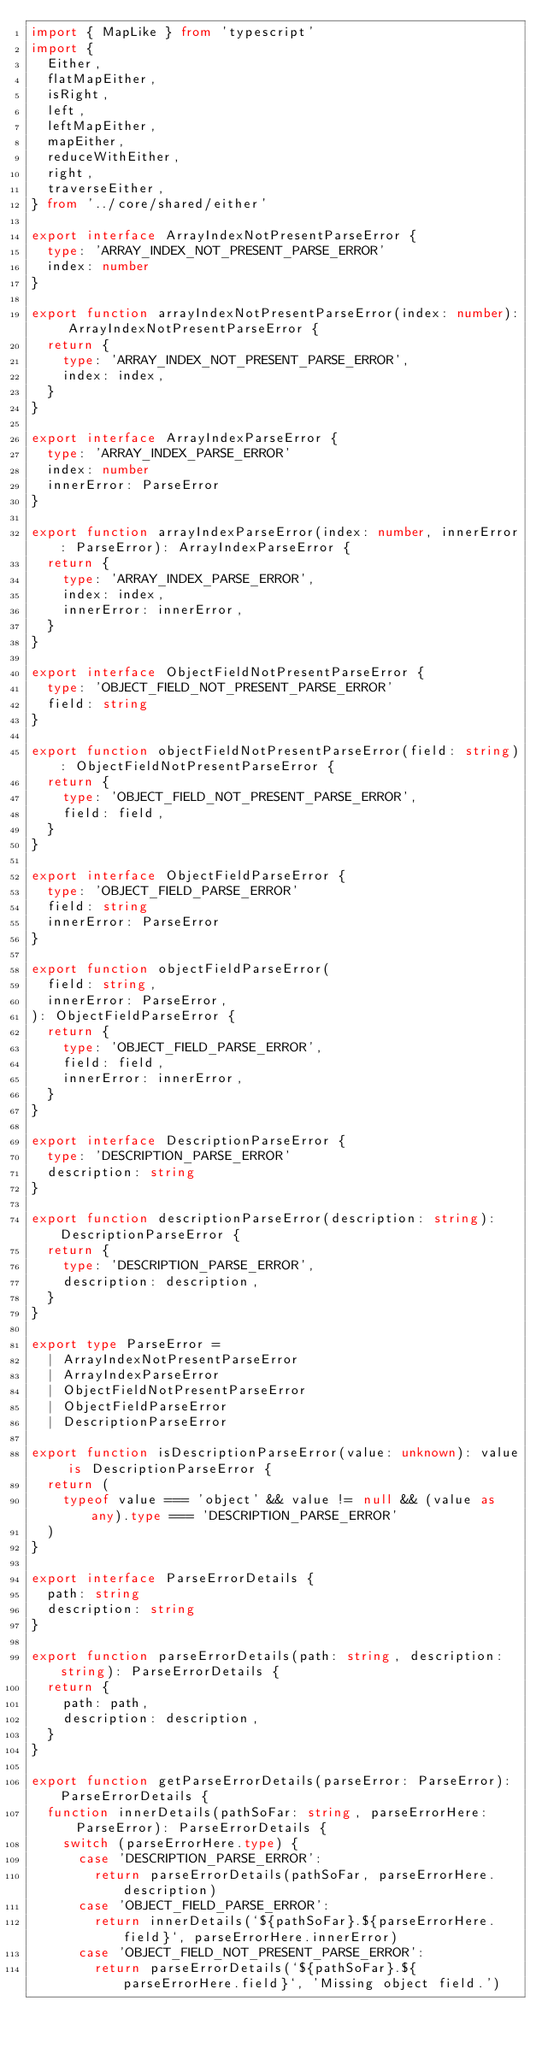Convert code to text. <code><loc_0><loc_0><loc_500><loc_500><_TypeScript_>import { MapLike } from 'typescript'
import {
  Either,
  flatMapEither,
  isRight,
  left,
  leftMapEither,
  mapEither,
  reduceWithEither,
  right,
  traverseEither,
} from '../core/shared/either'

export interface ArrayIndexNotPresentParseError {
  type: 'ARRAY_INDEX_NOT_PRESENT_PARSE_ERROR'
  index: number
}

export function arrayIndexNotPresentParseError(index: number): ArrayIndexNotPresentParseError {
  return {
    type: 'ARRAY_INDEX_NOT_PRESENT_PARSE_ERROR',
    index: index,
  }
}

export interface ArrayIndexParseError {
  type: 'ARRAY_INDEX_PARSE_ERROR'
  index: number
  innerError: ParseError
}

export function arrayIndexParseError(index: number, innerError: ParseError): ArrayIndexParseError {
  return {
    type: 'ARRAY_INDEX_PARSE_ERROR',
    index: index,
    innerError: innerError,
  }
}

export interface ObjectFieldNotPresentParseError {
  type: 'OBJECT_FIELD_NOT_PRESENT_PARSE_ERROR'
  field: string
}

export function objectFieldNotPresentParseError(field: string): ObjectFieldNotPresentParseError {
  return {
    type: 'OBJECT_FIELD_NOT_PRESENT_PARSE_ERROR',
    field: field,
  }
}

export interface ObjectFieldParseError {
  type: 'OBJECT_FIELD_PARSE_ERROR'
  field: string
  innerError: ParseError
}

export function objectFieldParseError(
  field: string,
  innerError: ParseError,
): ObjectFieldParseError {
  return {
    type: 'OBJECT_FIELD_PARSE_ERROR',
    field: field,
    innerError: innerError,
  }
}

export interface DescriptionParseError {
  type: 'DESCRIPTION_PARSE_ERROR'
  description: string
}

export function descriptionParseError(description: string): DescriptionParseError {
  return {
    type: 'DESCRIPTION_PARSE_ERROR',
    description: description,
  }
}

export type ParseError =
  | ArrayIndexNotPresentParseError
  | ArrayIndexParseError
  | ObjectFieldNotPresentParseError
  | ObjectFieldParseError
  | DescriptionParseError

export function isDescriptionParseError(value: unknown): value is DescriptionParseError {
  return (
    typeof value === 'object' && value != null && (value as any).type === 'DESCRIPTION_PARSE_ERROR'
  )
}

export interface ParseErrorDetails {
  path: string
  description: string
}

export function parseErrorDetails(path: string, description: string): ParseErrorDetails {
  return {
    path: path,
    description: description,
  }
}

export function getParseErrorDetails(parseError: ParseError): ParseErrorDetails {
  function innerDetails(pathSoFar: string, parseErrorHere: ParseError): ParseErrorDetails {
    switch (parseErrorHere.type) {
      case 'DESCRIPTION_PARSE_ERROR':
        return parseErrorDetails(pathSoFar, parseErrorHere.description)
      case 'OBJECT_FIELD_PARSE_ERROR':
        return innerDetails(`${pathSoFar}.${parseErrorHere.field}`, parseErrorHere.innerError)
      case 'OBJECT_FIELD_NOT_PRESENT_PARSE_ERROR':
        return parseErrorDetails(`${pathSoFar}.${parseErrorHere.field}`, 'Missing object field.')</code> 